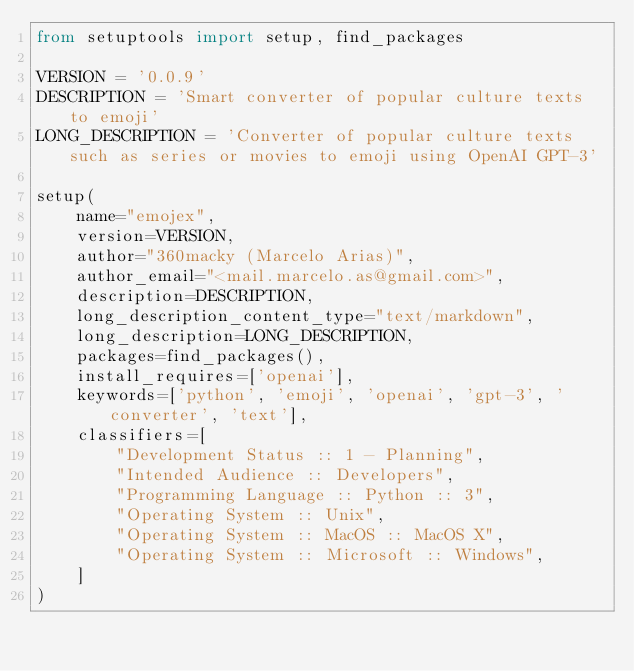<code> <loc_0><loc_0><loc_500><loc_500><_Python_>from setuptools import setup, find_packages

VERSION = '0.0.9'
DESCRIPTION = 'Smart converter of popular culture texts to emoji'
LONG_DESCRIPTION = 'Converter of popular culture texts such as series or movies to emoji using OpenAI GPT-3'

setup(
    name="emojex",
    version=VERSION,
    author="360macky (Marcelo Arias)",
    author_email="<mail.marcelo.as@gmail.com>",
    description=DESCRIPTION,
    long_description_content_type="text/markdown",
    long_description=LONG_DESCRIPTION,
    packages=find_packages(),
    install_requires=['openai'],
    keywords=['python', 'emoji', 'openai', 'gpt-3', 'converter', 'text'],
    classifiers=[
        "Development Status :: 1 - Planning",
        "Intended Audience :: Developers",
        "Programming Language :: Python :: 3",
        "Operating System :: Unix",
        "Operating System :: MacOS :: MacOS X",
        "Operating System :: Microsoft :: Windows",
    ]
)
</code> 